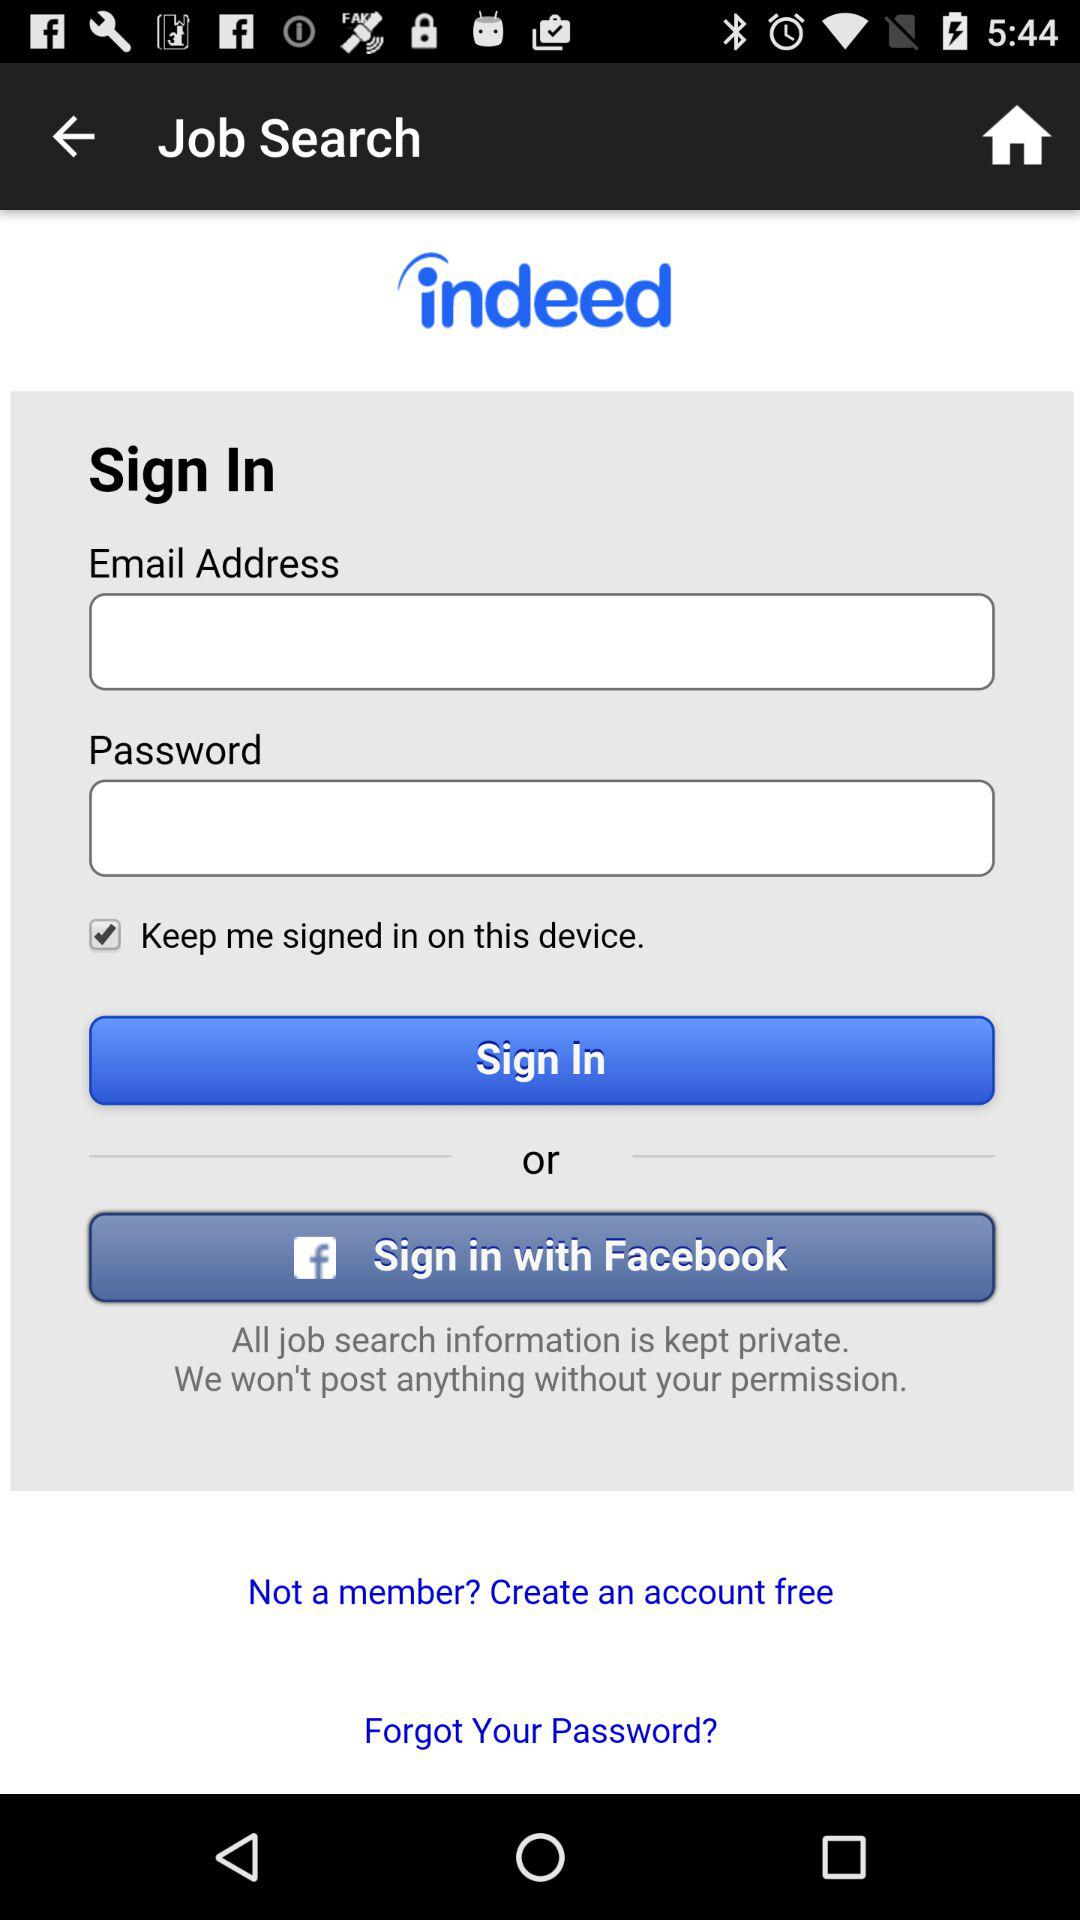How many text inputs are on the screen?
Answer the question using a single word or phrase. 2 